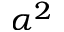Convert formula to latex. <formula><loc_0><loc_0><loc_500><loc_500>\alpha ^ { 2 }</formula> 